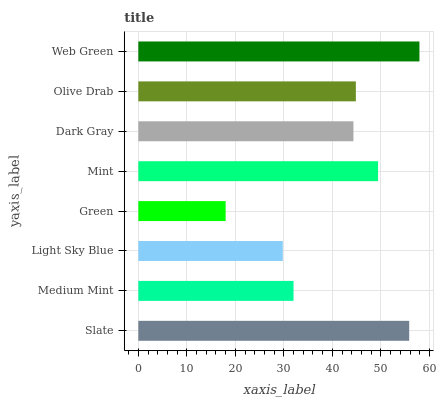Is Green the minimum?
Answer yes or no. Yes. Is Web Green the maximum?
Answer yes or no. Yes. Is Medium Mint the minimum?
Answer yes or no. No. Is Medium Mint the maximum?
Answer yes or no. No. Is Slate greater than Medium Mint?
Answer yes or no. Yes. Is Medium Mint less than Slate?
Answer yes or no. Yes. Is Medium Mint greater than Slate?
Answer yes or no. No. Is Slate less than Medium Mint?
Answer yes or no. No. Is Olive Drab the high median?
Answer yes or no. Yes. Is Dark Gray the low median?
Answer yes or no. Yes. Is Dark Gray the high median?
Answer yes or no. No. Is Slate the low median?
Answer yes or no. No. 